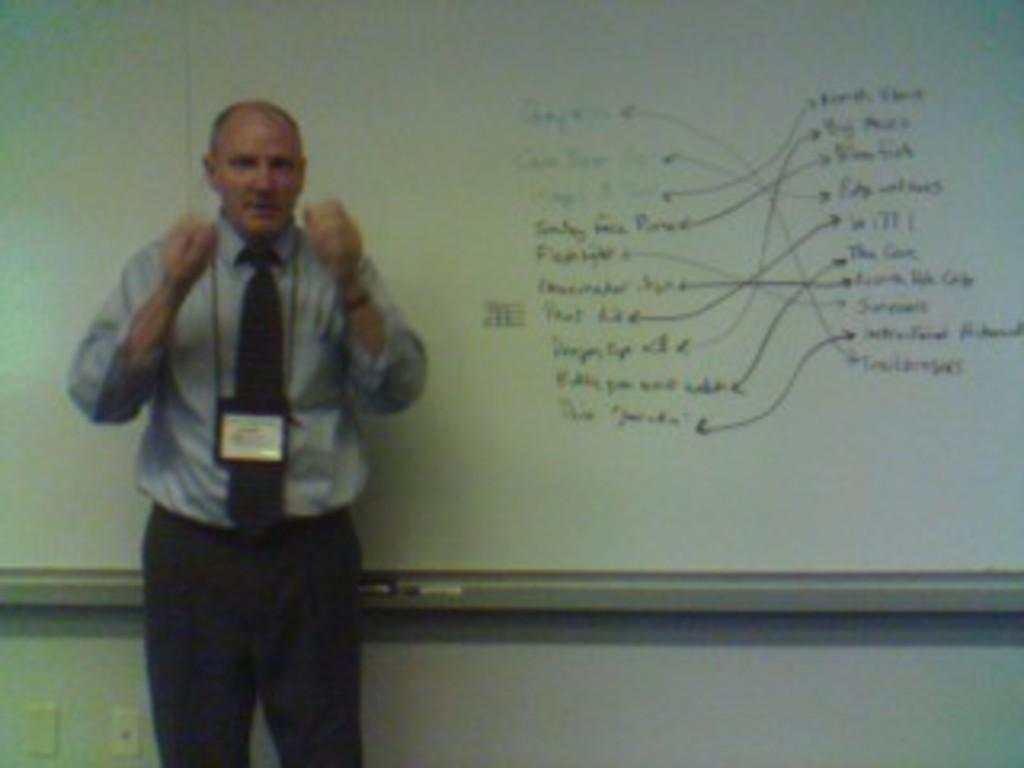What is the main subject of the image? There is a person standing in the image. What can be seen around the person's neck? The person is wearing a tag around their neck. What is located beside the person in the image? There is a board with text beside the person. What type of underwear is the person wearing in the image? There is no information about the person's underwear in the image, so it cannot be determined. What type of cloth is used to make the board in the image? The image does not provide information about the material used to make the board, so it cannot be determined. 